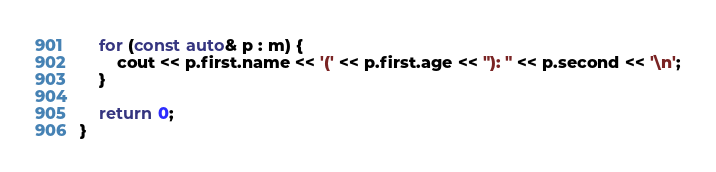<code> <loc_0><loc_0><loc_500><loc_500><_C++_>    for (const auto& p : m) {
        cout << p.first.name << '(' << p.first.age << "): " << p.second << '\n';
    }

    return 0;
}</code> 